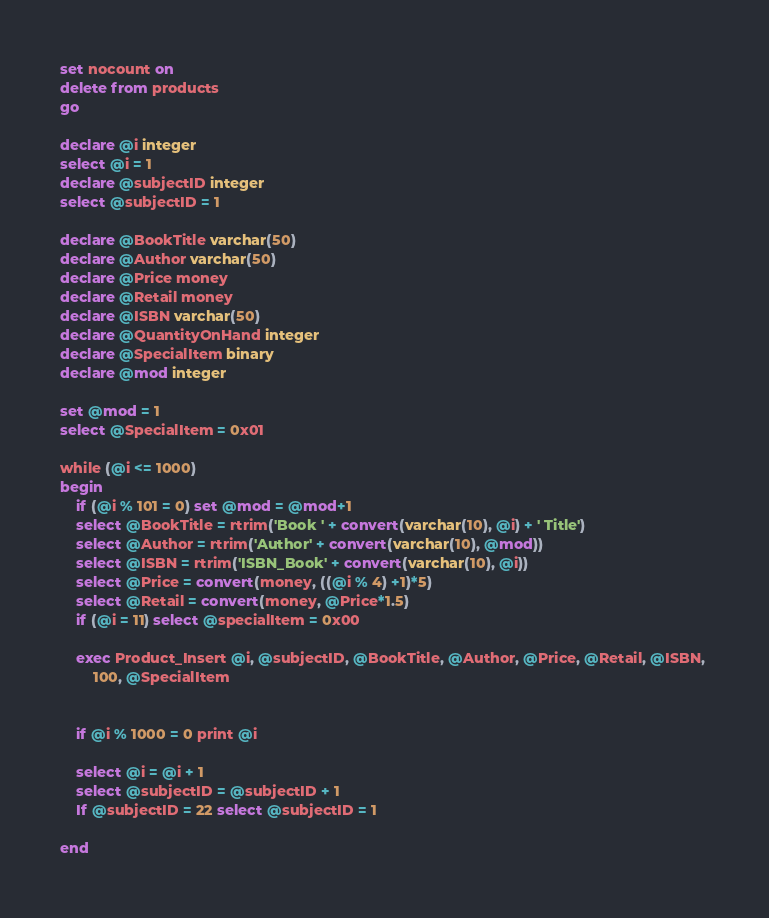Convert code to text. <code><loc_0><loc_0><loc_500><loc_500><_SQL_>set nocount on
delete from products
go

declare @i integer
select @i = 1
declare @subjectID integer
select @subjectID = 1

declare @BookTitle varchar(50)
declare @Author varchar(50)
declare @Price money
declare @Retail money
declare @ISBN varchar(50)
declare @QuantityOnHand integer
declare @SpecialItem binary
declare @mod integer

set @mod = 1
select @SpecialItem = 0x01

while (@i <= 1000)
begin
	if (@i % 101 = 0) set @mod = @mod+1
	select @BookTitle = rtrim('Book ' + convert(varchar(10), @i) + ' Title')
	select @Author = rtrim('Author' + convert(varchar(10), @mod))
	select @ISBN = rtrim('ISBN_Book' + convert(varchar(10), @i))
	select @Price = convert(money, ((@i % 4) +1)*5)
	select @Retail = convert(money, @Price*1.5)
	if (@i = 11) select @specialItem = 0x00

	exec Product_Insert @i, @subjectID, @BookTitle, @Author, @Price, @Retail, @ISBN, 
		100, @SpecialItem
	

	if @i % 1000 = 0 print @i

	select @i = @i + 1
	select @subjectID = @subjectID + 1
	If @subjectID = 22 select @subjectID = 1 

end

</code> 